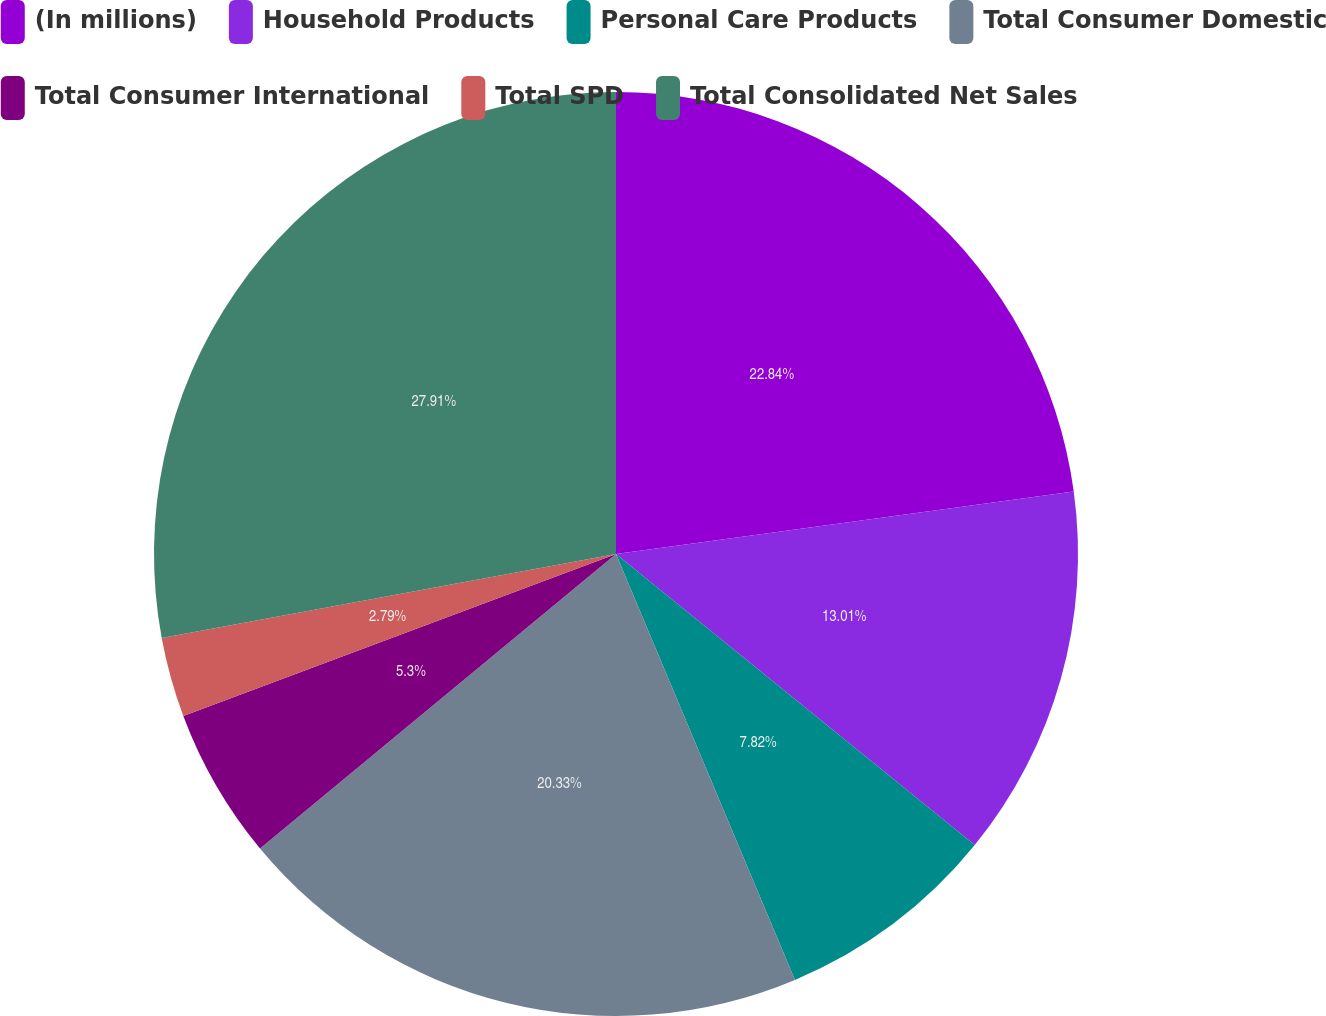<chart> <loc_0><loc_0><loc_500><loc_500><pie_chart><fcel>(In millions)<fcel>Household Products<fcel>Personal Care Products<fcel>Total Consumer Domestic<fcel>Total Consumer International<fcel>Total SPD<fcel>Total Consolidated Net Sales<nl><fcel>22.84%<fcel>13.01%<fcel>7.82%<fcel>20.33%<fcel>5.3%<fcel>2.79%<fcel>27.91%<nl></chart> 